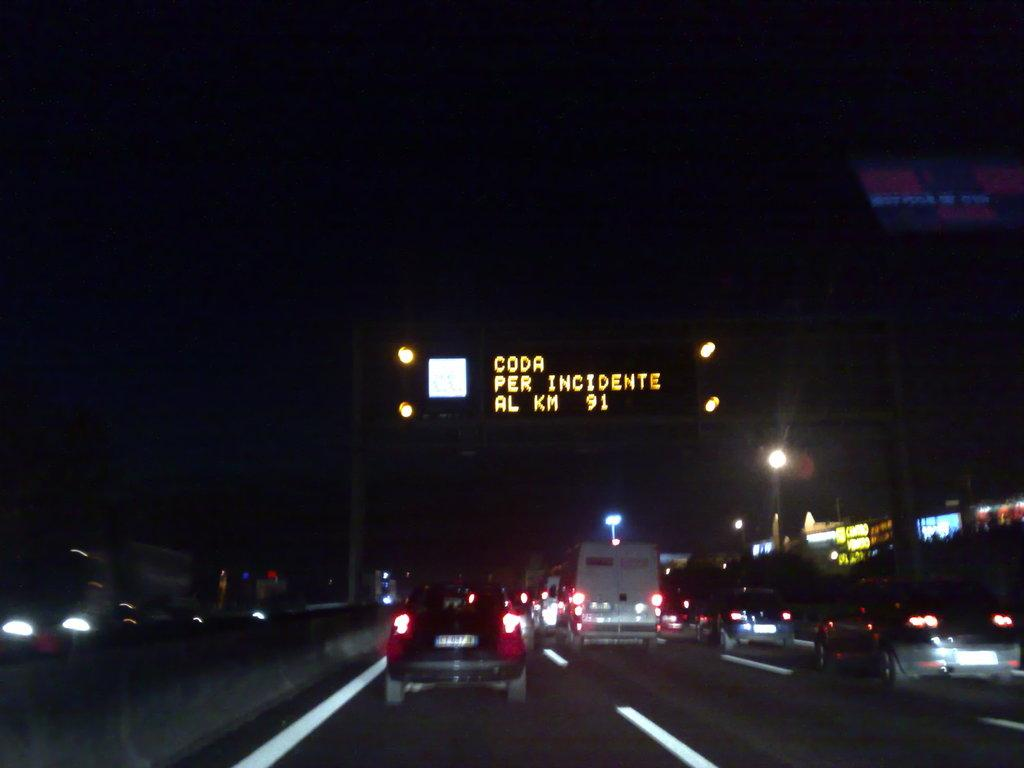What can be seen on the road in the image? There are vehicles on the road in the image. What type of illumination is present in the image? There are lights and light poles in the image. What electronic device is visible in the image? There is a digital board in the image. What type of vegetation is present in the image? There are plants in the image. What type of structures are visible in the image? There are buildings in the image. How would you describe the background of the image? The background of the image is dark. Can you tell me how many laborers are working on the expansion of the building in the image? There is no laborer or expansion work present in the image. What type of control system is used to manage the traffic in the image? The image does not show any control system for managing traffic. 